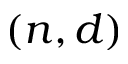<formula> <loc_0><loc_0><loc_500><loc_500>( n , d )</formula> 